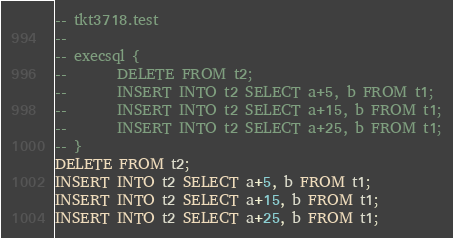<code> <loc_0><loc_0><loc_500><loc_500><_SQL_>-- tkt3718.test
-- 
-- execsql { 
--       DELETE FROM t2;
--       INSERT INTO t2 SELECT a+5, b FROM t1;
--       INSERT INTO t2 SELECT a+15, b FROM t1;
--       INSERT INTO t2 SELECT a+25, b FROM t1;
-- }
DELETE FROM t2;
INSERT INTO t2 SELECT a+5, b FROM t1;
INSERT INTO t2 SELECT a+15, b FROM t1;
INSERT INTO t2 SELECT a+25, b FROM t1;</code> 